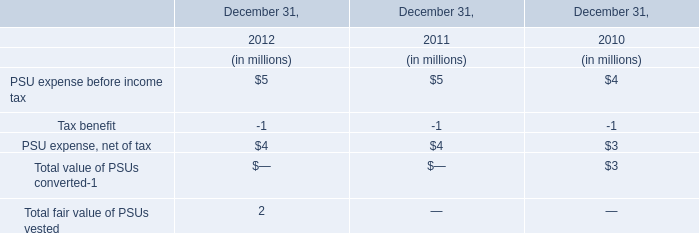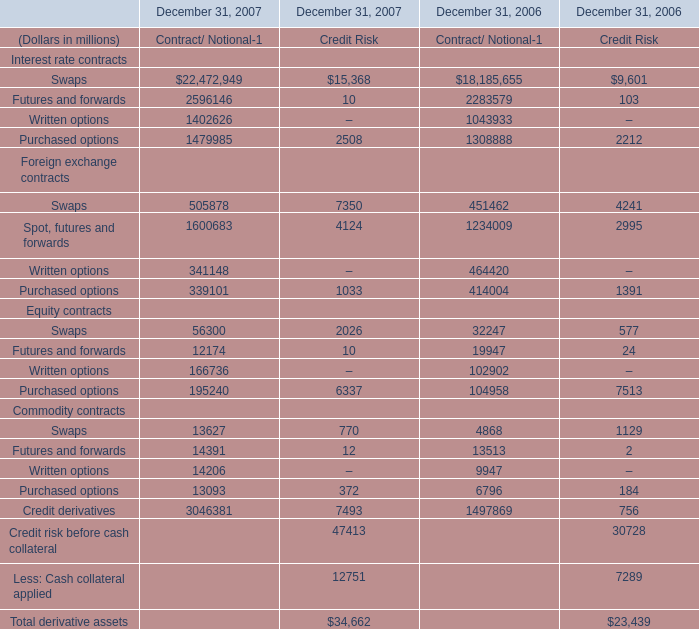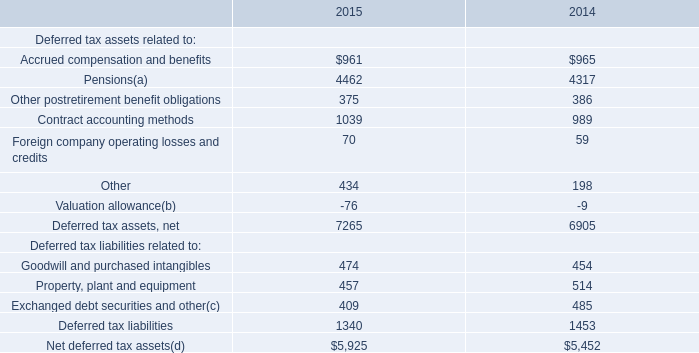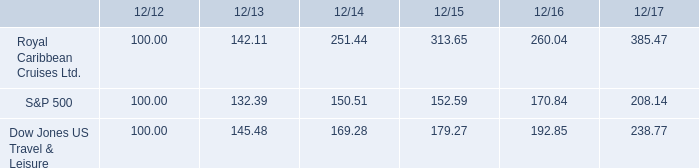What's the sum of Purchased options Commodity contracts of December 31, 2007 Contract/ Notional, and Deferred tax assets, net of 2014 ? 
Computations: (13093.0 + 6905.0)
Answer: 19998.0. 